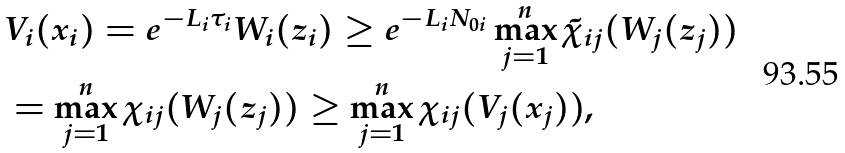Convert formula to latex. <formula><loc_0><loc_0><loc_500><loc_500>& V _ { i } ( x _ { i } ) = e ^ { - L _ { i } \tau _ { i } } W _ { i } ( z _ { i } ) \geq e ^ { - L _ { i } N _ { 0 i } } \max _ { j = 1 } ^ { n } \tilde { \chi } _ { i j } ( W _ { j } ( z _ { j } ) ) \\ & = \max _ { j = 1 } ^ { n } \chi _ { i j } ( W _ { j } ( z _ { j } ) ) \geq \max _ { j = 1 } ^ { n } \chi _ { i j } ( V _ { j } ( x _ { j } ) ) ,</formula> 